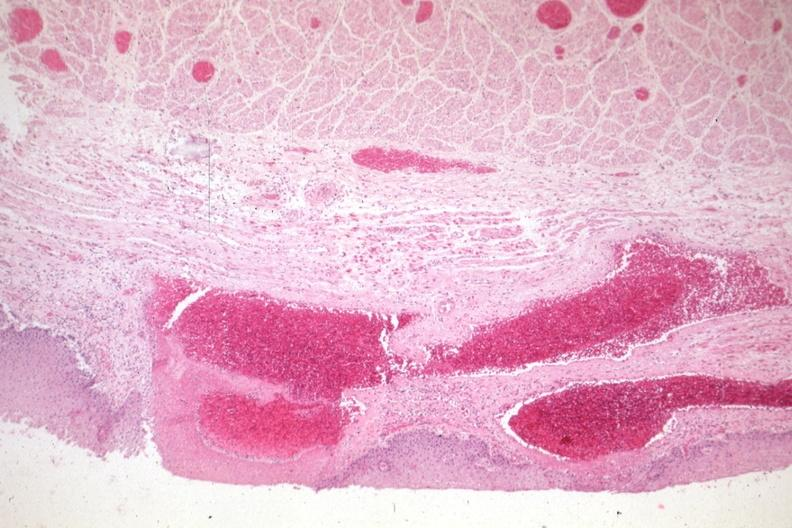s medial aspect present?
Answer the question using a single word or phrase. No 